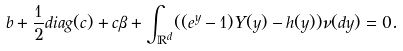Convert formula to latex. <formula><loc_0><loc_0><loc_500><loc_500>b + \frac { 1 } { 2 } d i a g ( c ) + c \beta + \int _ { \mathbb { R } ^ { d } } ( ( e ^ { y } - 1 ) Y ( y ) - h ( y ) ) \nu ( d y ) = 0 .</formula> 